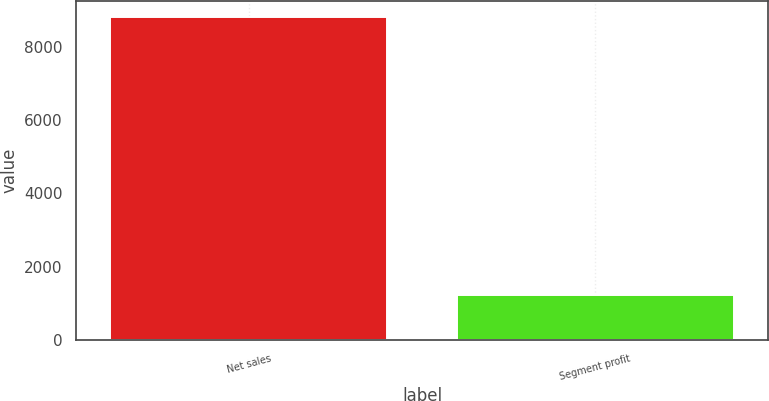Convert chart to OTSL. <chart><loc_0><loc_0><loc_500><loc_500><bar_chart><fcel>Net sales<fcel>Segment profit<nl><fcel>8813<fcel>1221<nl></chart> 